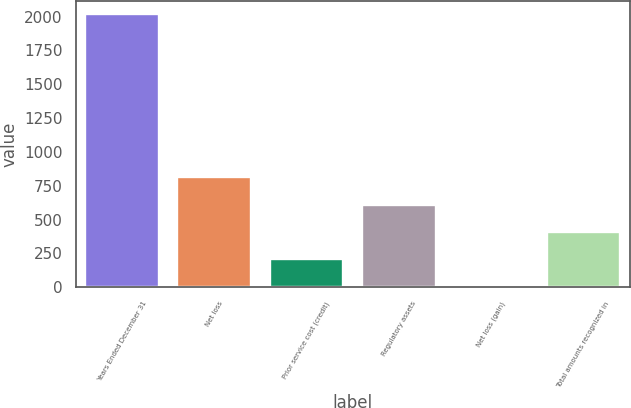Convert chart. <chart><loc_0><loc_0><loc_500><loc_500><bar_chart><fcel>Years Ended December 31<fcel>Net loss<fcel>Prior service cost (credit)<fcel>Regulatory assets<fcel>Net loss (gain)<fcel>Total amounts recognized in<nl><fcel>2016<fcel>811.2<fcel>208.8<fcel>610.4<fcel>8<fcel>409.6<nl></chart> 